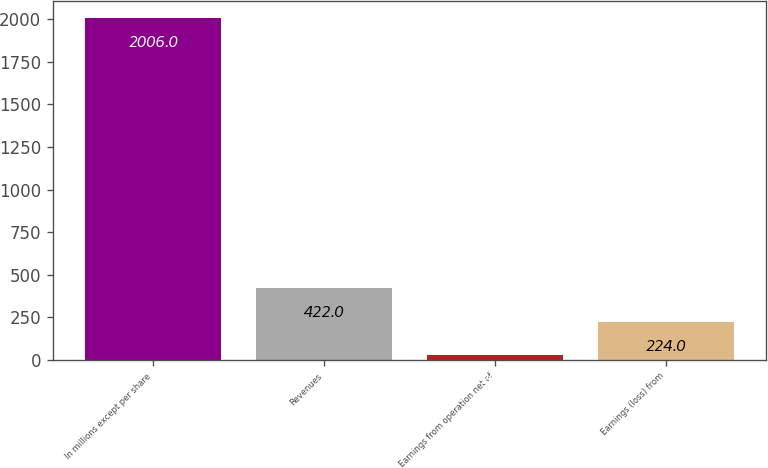<chart> <loc_0><loc_0><loc_500><loc_500><bar_chart><fcel>In millions except per share<fcel>Revenues<fcel>Earnings from operation net of<fcel>Earnings (loss) from<nl><fcel>2006<fcel>422<fcel>26<fcel>224<nl></chart> 